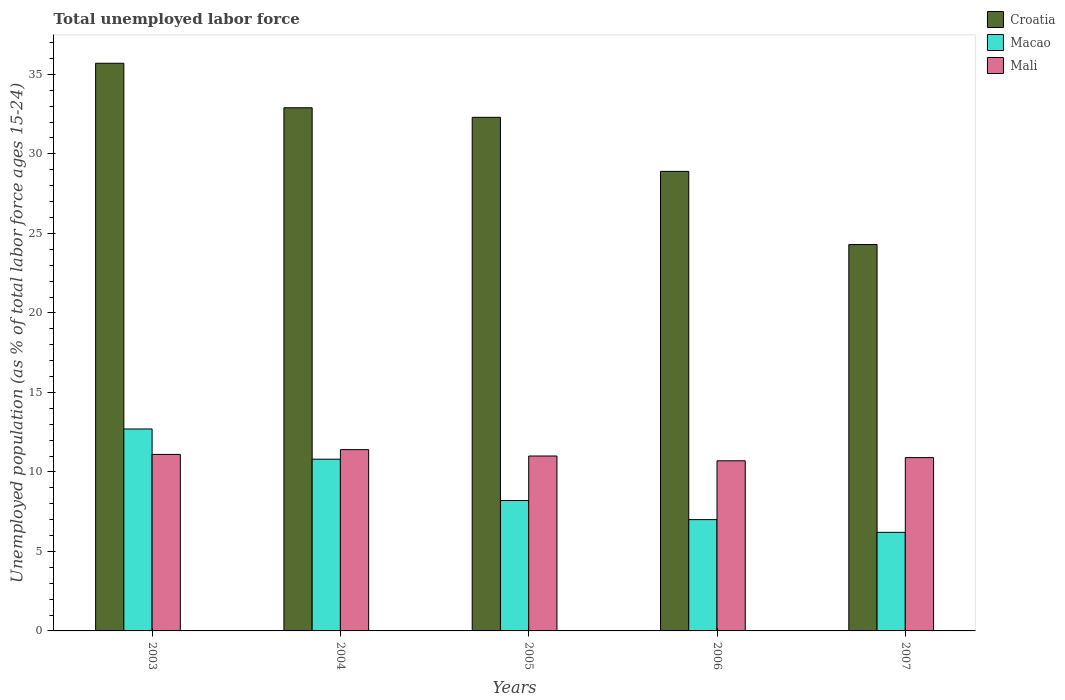How many different coloured bars are there?
Provide a short and direct response. 3. Are the number of bars on each tick of the X-axis equal?
Offer a terse response. Yes. How many bars are there on the 3rd tick from the left?
Provide a succinct answer. 3. How many bars are there on the 3rd tick from the right?
Your answer should be very brief. 3. What is the label of the 3rd group of bars from the left?
Provide a short and direct response. 2005. What is the percentage of unemployed population in in Croatia in 2004?
Your answer should be very brief. 32.9. Across all years, what is the maximum percentage of unemployed population in in Croatia?
Give a very brief answer. 35.7. Across all years, what is the minimum percentage of unemployed population in in Croatia?
Ensure brevity in your answer.  24.3. In which year was the percentage of unemployed population in in Macao maximum?
Your answer should be compact. 2003. In which year was the percentage of unemployed population in in Croatia minimum?
Keep it short and to the point. 2007. What is the total percentage of unemployed population in in Macao in the graph?
Ensure brevity in your answer.  44.9. What is the difference between the percentage of unemployed population in in Croatia in 2003 and that in 2004?
Make the answer very short. 2.8. What is the difference between the percentage of unemployed population in in Mali in 2007 and the percentage of unemployed population in in Croatia in 2004?
Offer a terse response. -22. What is the average percentage of unemployed population in in Croatia per year?
Your answer should be compact. 30.82. In the year 2004, what is the difference between the percentage of unemployed population in in Croatia and percentage of unemployed population in in Macao?
Your response must be concise. 22.1. In how many years, is the percentage of unemployed population in in Mali greater than 12 %?
Keep it short and to the point. 0. What is the ratio of the percentage of unemployed population in in Mali in 2005 to that in 2006?
Keep it short and to the point. 1.03. What is the difference between the highest and the second highest percentage of unemployed population in in Croatia?
Provide a short and direct response. 2.8. What is the difference between the highest and the lowest percentage of unemployed population in in Macao?
Give a very brief answer. 6.5. What does the 3rd bar from the left in 2005 represents?
Ensure brevity in your answer.  Mali. What does the 3rd bar from the right in 2003 represents?
Ensure brevity in your answer.  Croatia. Is it the case that in every year, the sum of the percentage of unemployed population in in Macao and percentage of unemployed population in in Croatia is greater than the percentage of unemployed population in in Mali?
Offer a very short reply. Yes. Are all the bars in the graph horizontal?
Ensure brevity in your answer.  No. How many years are there in the graph?
Keep it short and to the point. 5. Does the graph contain grids?
Give a very brief answer. No. How are the legend labels stacked?
Your response must be concise. Vertical. What is the title of the graph?
Keep it short and to the point. Total unemployed labor force. Does "Chile" appear as one of the legend labels in the graph?
Provide a short and direct response. No. What is the label or title of the Y-axis?
Keep it short and to the point. Unemployed population (as % of total labor force ages 15-24). What is the Unemployed population (as % of total labor force ages 15-24) of Croatia in 2003?
Your answer should be very brief. 35.7. What is the Unemployed population (as % of total labor force ages 15-24) in Macao in 2003?
Give a very brief answer. 12.7. What is the Unemployed population (as % of total labor force ages 15-24) in Mali in 2003?
Offer a very short reply. 11.1. What is the Unemployed population (as % of total labor force ages 15-24) of Croatia in 2004?
Offer a very short reply. 32.9. What is the Unemployed population (as % of total labor force ages 15-24) in Macao in 2004?
Your answer should be very brief. 10.8. What is the Unemployed population (as % of total labor force ages 15-24) in Mali in 2004?
Ensure brevity in your answer.  11.4. What is the Unemployed population (as % of total labor force ages 15-24) in Croatia in 2005?
Give a very brief answer. 32.3. What is the Unemployed population (as % of total labor force ages 15-24) in Macao in 2005?
Offer a terse response. 8.2. What is the Unemployed population (as % of total labor force ages 15-24) in Mali in 2005?
Provide a succinct answer. 11. What is the Unemployed population (as % of total labor force ages 15-24) in Croatia in 2006?
Make the answer very short. 28.9. What is the Unemployed population (as % of total labor force ages 15-24) in Macao in 2006?
Keep it short and to the point. 7. What is the Unemployed population (as % of total labor force ages 15-24) in Mali in 2006?
Your response must be concise. 10.7. What is the Unemployed population (as % of total labor force ages 15-24) of Croatia in 2007?
Offer a very short reply. 24.3. What is the Unemployed population (as % of total labor force ages 15-24) in Macao in 2007?
Your answer should be compact. 6.2. What is the Unemployed population (as % of total labor force ages 15-24) in Mali in 2007?
Ensure brevity in your answer.  10.9. Across all years, what is the maximum Unemployed population (as % of total labor force ages 15-24) in Croatia?
Offer a very short reply. 35.7. Across all years, what is the maximum Unemployed population (as % of total labor force ages 15-24) in Macao?
Provide a short and direct response. 12.7. Across all years, what is the maximum Unemployed population (as % of total labor force ages 15-24) of Mali?
Provide a succinct answer. 11.4. Across all years, what is the minimum Unemployed population (as % of total labor force ages 15-24) of Croatia?
Provide a short and direct response. 24.3. Across all years, what is the minimum Unemployed population (as % of total labor force ages 15-24) of Macao?
Your answer should be compact. 6.2. Across all years, what is the minimum Unemployed population (as % of total labor force ages 15-24) of Mali?
Ensure brevity in your answer.  10.7. What is the total Unemployed population (as % of total labor force ages 15-24) in Croatia in the graph?
Your answer should be very brief. 154.1. What is the total Unemployed population (as % of total labor force ages 15-24) of Macao in the graph?
Provide a succinct answer. 44.9. What is the total Unemployed population (as % of total labor force ages 15-24) of Mali in the graph?
Provide a short and direct response. 55.1. What is the difference between the Unemployed population (as % of total labor force ages 15-24) in Croatia in 2003 and that in 2004?
Your response must be concise. 2.8. What is the difference between the Unemployed population (as % of total labor force ages 15-24) in Croatia in 2003 and that in 2005?
Your answer should be compact. 3.4. What is the difference between the Unemployed population (as % of total labor force ages 15-24) of Mali in 2003 and that in 2005?
Give a very brief answer. 0.1. What is the difference between the Unemployed population (as % of total labor force ages 15-24) in Mali in 2003 and that in 2006?
Your answer should be very brief. 0.4. What is the difference between the Unemployed population (as % of total labor force ages 15-24) of Croatia in 2003 and that in 2007?
Give a very brief answer. 11.4. What is the difference between the Unemployed population (as % of total labor force ages 15-24) in Macao in 2003 and that in 2007?
Your response must be concise. 6.5. What is the difference between the Unemployed population (as % of total labor force ages 15-24) in Mali in 2003 and that in 2007?
Offer a very short reply. 0.2. What is the difference between the Unemployed population (as % of total labor force ages 15-24) of Croatia in 2004 and that in 2005?
Your answer should be compact. 0.6. What is the difference between the Unemployed population (as % of total labor force ages 15-24) in Macao in 2004 and that in 2006?
Give a very brief answer. 3.8. What is the difference between the Unemployed population (as % of total labor force ages 15-24) in Mali in 2004 and that in 2006?
Your answer should be very brief. 0.7. What is the difference between the Unemployed population (as % of total labor force ages 15-24) of Croatia in 2004 and that in 2007?
Provide a succinct answer. 8.6. What is the difference between the Unemployed population (as % of total labor force ages 15-24) of Macao in 2005 and that in 2006?
Provide a succinct answer. 1.2. What is the difference between the Unemployed population (as % of total labor force ages 15-24) of Croatia in 2005 and that in 2007?
Your answer should be compact. 8. What is the difference between the Unemployed population (as % of total labor force ages 15-24) in Croatia in 2006 and that in 2007?
Make the answer very short. 4.6. What is the difference between the Unemployed population (as % of total labor force ages 15-24) in Macao in 2006 and that in 2007?
Provide a succinct answer. 0.8. What is the difference between the Unemployed population (as % of total labor force ages 15-24) of Mali in 2006 and that in 2007?
Your answer should be compact. -0.2. What is the difference between the Unemployed population (as % of total labor force ages 15-24) in Croatia in 2003 and the Unemployed population (as % of total labor force ages 15-24) in Macao in 2004?
Your response must be concise. 24.9. What is the difference between the Unemployed population (as % of total labor force ages 15-24) in Croatia in 2003 and the Unemployed population (as % of total labor force ages 15-24) in Mali in 2004?
Provide a succinct answer. 24.3. What is the difference between the Unemployed population (as % of total labor force ages 15-24) in Macao in 2003 and the Unemployed population (as % of total labor force ages 15-24) in Mali in 2004?
Make the answer very short. 1.3. What is the difference between the Unemployed population (as % of total labor force ages 15-24) in Croatia in 2003 and the Unemployed population (as % of total labor force ages 15-24) in Mali in 2005?
Provide a succinct answer. 24.7. What is the difference between the Unemployed population (as % of total labor force ages 15-24) of Croatia in 2003 and the Unemployed population (as % of total labor force ages 15-24) of Macao in 2006?
Ensure brevity in your answer.  28.7. What is the difference between the Unemployed population (as % of total labor force ages 15-24) of Croatia in 2003 and the Unemployed population (as % of total labor force ages 15-24) of Mali in 2006?
Provide a succinct answer. 25. What is the difference between the Unemployed population (as % of total labor force ages 15-24) in Macao in 2003 and the Unemployed population (as % of total labor force ages 15-24) in Mali in 2006?
Keep it short and to the point. 2. What is the difference between the Unemployed population (as % of total labor force ages 15-24) of Croatia in 2003 and the Unemployed population (as % of total labor force ages 15-24) of Macao in 2007?
Your answer should be compact. 29.5. What is the difference between the Unemployed population (as % of total labor force ages 15-24) in Croatia in 2003 and the Unemployed population (as % of total labor force ages 15-24) in Mali in 2007?
Your response must be concise. 24.8. What is the difference between the Unemployed population (as % of total labor force ages 15-24) in Croatia in 2004 and the Unemployed population (as % of total labor force ages 15-24) in Macao in 2005?
Give a very brief answer. 24.7. What is the difference between the Unemployed population (as % of total labor force ages 15-24) in Croatia in 2004 and the Unemployed population (as % of total labor force ages 15-24) in Mali in 2005?
Offer a terse response. 21.9. What is the difference between the Unemployed population (as % of total labor force ages 15-24) of Croatia in 2004 and the Unemployed population (as % of total labor force ages 15-24) of Macao in 2006?
Give a very brief answer. 25.9. What is the difference between the Unemployed population (as % of total labor force ages 15-24) in Croatia in 2004 and the Unemployed population (as % of total labor force ages 15-24) in Mali in 2006?
Your answer should be very brief. 22.2. What is the difference between the Unemployed population (as % of total labor force ages 15-24) of Macao in 2004 and the Unemployed population (as % of total labor force ages 15-24) of Mali in 2006?
Offer a very short reply. 0.1. What is the difference between the Unemployed population (as % of total labor force ages 15-24) of Croatia in 2004 and the Unemployed population (as % of total labor force ages 15-24) of Macao in 2007?
Offer a very short reply. 26.7. What is the difference between the Unemployed population (as % of total labor force ages 15-24) of Macao in 2004 and the Unemployed population (as % of total labor force ages 15-24) of Mali in 2007?
Ensure brevity in your answer.  -0.1. What is the difference between the Unemployed population (as % of total labor force ages 15-24) in Croatia in 2005 and the Unemployed population (as % of total labor force ages 15-24) in Macao in 2006?
Ensure brevity in your answer.  25.3. What is the difference between the Unemployed population (as % of total labor force ages 15-24) of Croatia in 2005 and the Unemployed population (as % of total labor force ages 15-24) of Mali in 2006?
Provide a succinct answer. 21.6. What is the difference between the Unemployed population (as % of total labor force ages 15-24) in Macao in 2005 and the Unemployed population (as % of total labor force ages 15-24) in Mali in 2006?
Offer a very short reply. -2.5. What is the difference between the Unemployed population (as % of total labor force ages 15-24) in Croatia in 2005 and the Unemployed population (as % of total labor force ages 15-24) in Macao in 2007?
Provide a short and direct response. 26.1. What is the difference between the Unemployed population (as % of total labor force ages 15-24) in Croatia in 2005 and the Unemployed population (as % of total labor force ages 15-24) in Mali in 2007?
Your answer should be compact. 21.4. What is the difference between the Unemployed population (as % of total labor force ages 15-24) of Macao in 2005 and the Unemployed population (as % of total labor force ages 15-24) of Mali in 2007?
Provide a succinct answer. -2.7. What is the difference between the Unemployed population (as % of total labor force ages 15-24) in Croatia in 2006 and the Unemployed population (as % of total labor force ages 15-24) in Macao in 2007?
Your answer should be compact. 22.7. What is the average Unemployed population (as % of total labor force ages 15-24) in Croatia per year?
Offer a terse response. 30.82. What is the average Unemployed population (as % of total labor force ages 15-24) in Macao per year?
Provide a short and direct response. 8.98. What is the average Unemployed population (as % of total labor force ages 15-24) in Mali per year?
Make the answer very short. 11.02. In the year 2003, what is the difference between the Unemployed population (as % of total labor force ages 15-24) of Croatia and Unemployed population (as % of total labor force ages 15-24) of Mali?
Ensure brevity in your answer.  24.6. In the year 2003, what is the difference between the Unemployed population (as % of total labor force ages 15-24) in Macao and Unemployed population (as % of total labor force ages 15-24) in Mali?
Your answer should be very brief. 1.6. In the year 2004, what is the difference between the Unemployed population (as % of total labor force ages 15-24) of Croatia and Unemployed population (as % of total labor force ages 15-24) of Macao?
Your response must be concise. 22.1. In the year 2005, what is the difference between the Unemployed population (as % of total labor force ages 15-24) in Croatia and Unemployed population (as % of total labor force ages 15-24) in Macao?
Offer a terse response. 24.1. In the year 2005, what is the difference between the Unemployed population (as % of total labor force ages 15-24) of Croatia and Unemployed population (as % of total labor force ages 15-24) of Mali?
Ensure brevity in your answer.  21.3. In the year 2005, what is the difference between the Unemployed population (as % of total labor force ages 15-24) of Macao and Unemployed population (as % of total labor force ages 15-24) of Mali?
Your answer should be very brief. -2.8. In the year 2006, what is the difference between the Unemployed population (as % of total labor force ages 15-24) in Croatia and Unemployed population (as % of total labor force ages 15-24) in Macao?
Provide a short and direct response. 21.9. In the year 2007, what is the difference between the Unemployed population (as % of total labor force ages 15-24) in Croatia and Unemployed population (as % of total labor force ages 15-24) in Macao?
Give a very brief answer. 18.1. In the year 2007, what is the difference between the Unemployed population (as % of total labor force ages 15-24) in Croatia and Unemployed population (as % of total labor force ages 15-24) in Mali?
Make the answer very short. 13.4. What is the ratio of the Unemployed population (as % of total labor force ages 15-24) in Croatia in 2003 to that in 2004?
Offer a terse response. 1.09. What is the ratio of the Unemployed population (as % of total labor force ages 15-24) in Macao in 2003 to that in 2004?
Give a very brief answer. 1.18. What is the ratio of the Unemployed population (as % of total labor force ages 15-24) of Mali in 2003 to that in 2004?
Provide a short and direct response. 0.97. What is the ratio of the Unemployed population (as % of total labor force ages 15-24) in Croatia in 2003 to that in 2005?
Provide a short and direct response. 1.11. What is the ratio of the Unemployed population (as % of total labor force ages 15-24) of Macao in 2003 to that in 2005?
Your answer should be very brief. 1.55. What is the ratio of the Unemployed population (as % of total labor force ages 15-24) in Mali in 2003 to that in 2005?
Your answer should be compact. 1.01. What is the ratio of the Unemployed population (as % of total labor force ages 15-24) of Croatia in 2003 to that in 2006?
Keep it short and to the point. 1.24. What is the ratio of the Unemployed population (as % of total labor force ages 15-24) of Macao in 2003 to that in 2006?
Your answer should be compact. 1.81. What is the ratio of the Unemployed population (as % of total labor force ages 15-24) of Mali in 2003 to that in 2006?
Your answer should be very brief. 1.04. What is the ratio of the Unemployed population (as % of total labor force ages 15-24) in Croatia in 2003 to that in 2007?
Provide a succinct answer. 1.47. What is the ratio of the Unemployed population (as % of total labor force ages 15-24) of Macao in 2003 to that in 2007?
Provide a succinct answer. 2.05. What is the ratio of the Unemployed population (as % of total labor force ages 15-24) in Mali in 2003 to that in 2007?
Give a very brief answer. 1.02. What is the ratio of the Unemployed population (as % of total labor force ages 15-24) in Croatia in 2004 to that in 2005?
Keep it short and to the point. 1.02. What is the ratio of the Unemployed population (as % of total labor force ages 15-24) in Macao in 2004 to that in 2005?
Keep it short and to the point. 1.32. What is the ratio of the Unemployed population (as % of total labor force ages 15-24) in Mali in 2004 to that in 2005?
Give a very brief answer. 1.04. What is the ratio of the Unemployed population (as % of total labor force ages 15-24) in Croatia in 2004 to that in 2006?
Your answer should be compact. 1.14. What is the ratio of the Unemployed population (as % of total labor force ages 15-24) of Macao in 2004 to that in 2006?
Your response must be concise. 1.54. What is the ratio of the Unemployed population (as % of total labor force ages 15-24) of Mali in 2004 to that in 2006?
Offer a very short reply. 1.07. What is the ratio of the Unemployed population (as % of total labor force ages 15-24) of Croatia in 2004 to that in 2007?
Your answer should be compact. 1.35. What is the ratio of the Unemployed population (as % of total labor force ages 15-24) in Macao in 2004 to that in 2007?
Offer a very short reply. 1.74. What is the ratio of the Unemployed population (as % of total labor force ages 15-24) in Mali in 2004 to that in 2007?
Make the answer very short. 1.05. What is the ratio of the Unemployed population (as % of total labor force ages 15-24) in Croatia in 2005 to that in 2006?
Offer a very short reply. 1.12. What is the ratio of the Unemployed population (as % of total labor force ages 15-24) in Macao in 2005 to that in 2006?
Your response must be concise. 1.17. What is the ratio of the Unemployed population (as % of total labor force ages 15-24) of Mali in 2005 to that in 2006?
Give a very brief answer. 1.03. What is the ratio of the Unemployed population (as % of total labor force ages 15-24) in Croatia in 2005 to that in 2007?
Give a very brief answer. 1.33. What is the ratio of the Unemployed population (as % of total labor force ages 15-24) of Macao in 2005 to that in 2007?
Your answer should be compact. 1.32. What is the ratio of the Unemployed population (as % of total labor force ages 15-24) of Mali in 2005 to that in 2007?
Give a very brief answer. 1.01. What is the ratio of the Unemployed population (as % of total labor force ages 15-24) of Croatia in 2006 to that in 2007?
Provide a succinct answer. 1.19. What is the ratio of the Unemployed population (as % of total labor force ages 15-24) of Macao in 2006 to that in 2007?
Offer a very short reply. 1.13. What is the ratio of the Unemployed population (as % of total labor force ages 15-24) in Mali in 2006 to that in 2007?
Your answer should be very brief. 0.98. What is the difference between the highest and the second highest Unemployed population (as % of total labor force ages 15-24) in Croatia?
Keep it short and to the point. 2.8. What is the difference between the highest and the second highest Unemployed population (as % of total labor force ages 15-24) in Mali?
Your answer should be very brief. 0.3. What is the difference between the highest and the lowest Unemployed population (as % of total labor force ages 15-24) in Mali?
Make the answer very short. 0.7. 